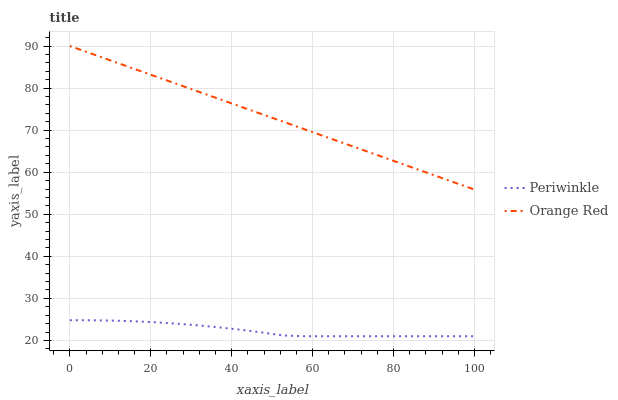Does Periwinkle have the minimum area under the curve?
Answer yes or no. Yes. Does Orange Red have the maximum area under the curve?
Answer yes or no. Yes. Does Orange Red have the minimum area under the curve?
Answer yes or no. No. Is Orange Red the smoothest?
Answer yes or no. Yes. Is Periwinkle the roughest?
Answer yes or no. Yes. Is Orange Red the roughest?
Answer yes or no. No. Does Periwinkle have the lowest value?
Answer yes or no. Yes. Does Orange Red have the lowest value?
Answer yes or no. No. Does Orange Red have the highest value?
Answer yes or no. Yes. Is Periwinkle less than Orange Red?
Answer yes or no. Yes. Is Orange Red greater than Periwinkle?
Answer yes or no. Yes. Does Periwinkle intersect Orange Red?
Answer yes or no. No. 